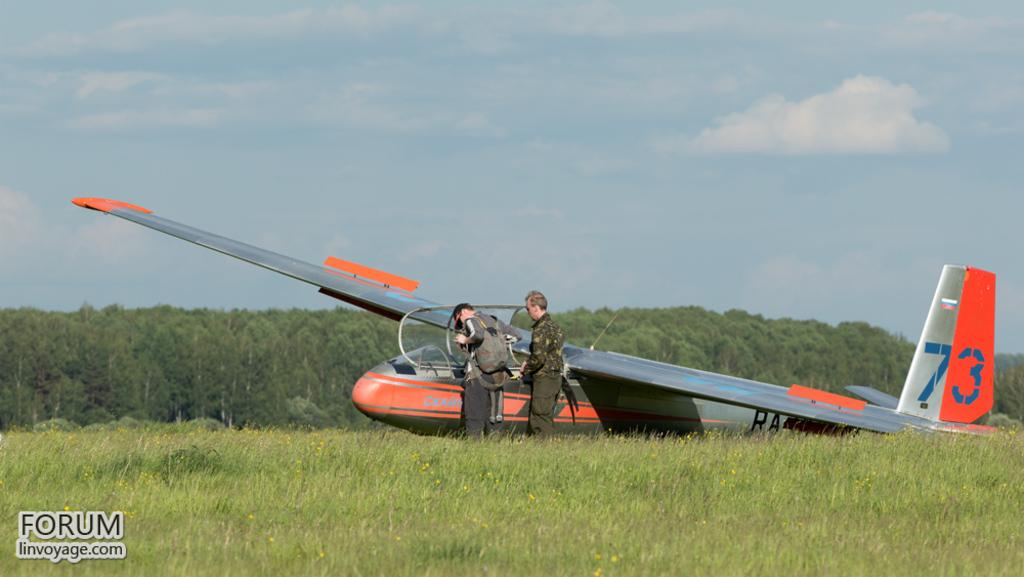<image>
Render a clear and concise summary of the photo. Two people in front of plane 73 taken from Forum linvoyage.com. 